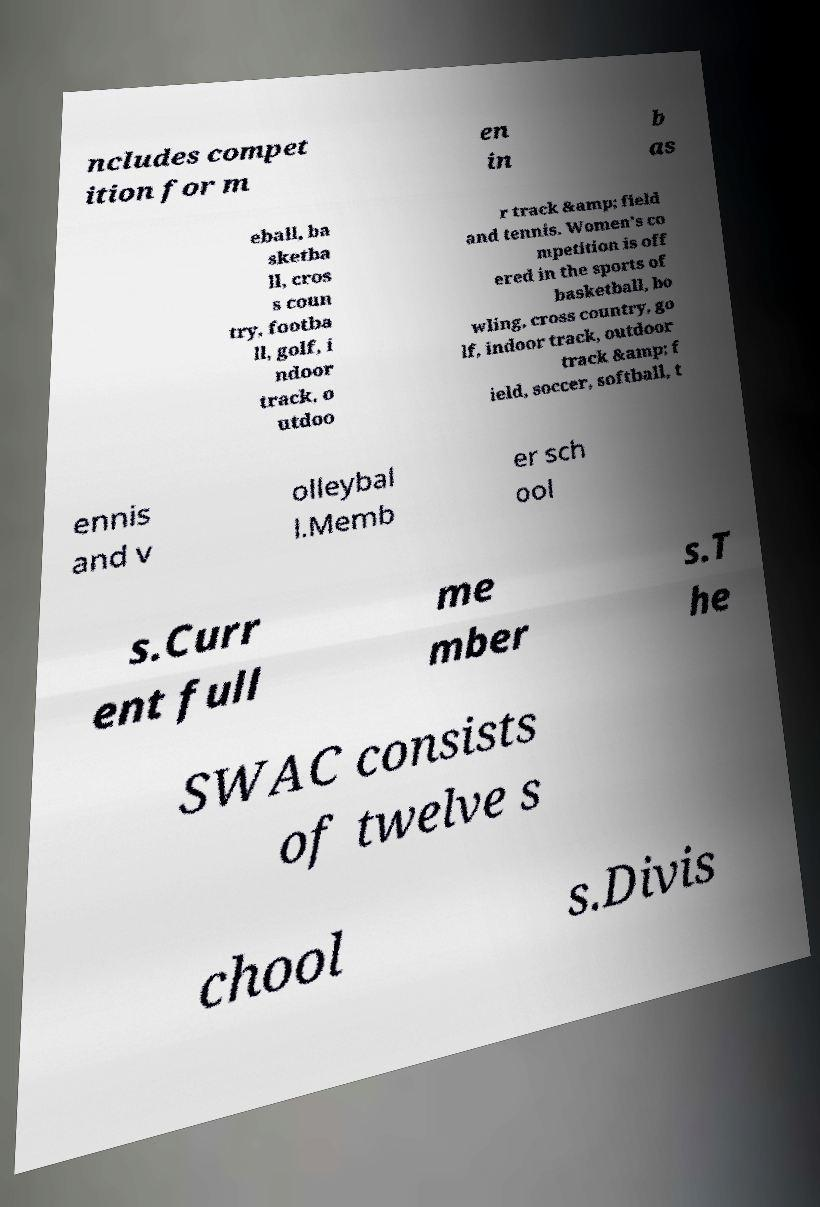Can you read and provide the text displayed in the image?This photo seems to have some interesting text. Can you extract and type it out for me? ncludes compet ition for m en in b as eball, ba sketba ll, cros s coun try, footba ll, golf, i ndoor track, o utdoo r track &amp; field and tennis. Women’s co mpetition is off ered in the sports of basketball, bo wling, cross country, go lf, indoor track, outdoor track &amp; f ield, soccer, softball, t ennis and v olleybal l.Memb er sch ool s.Curr ent full me mber s.T he SWAC consists of twelve s chool s.Divis 